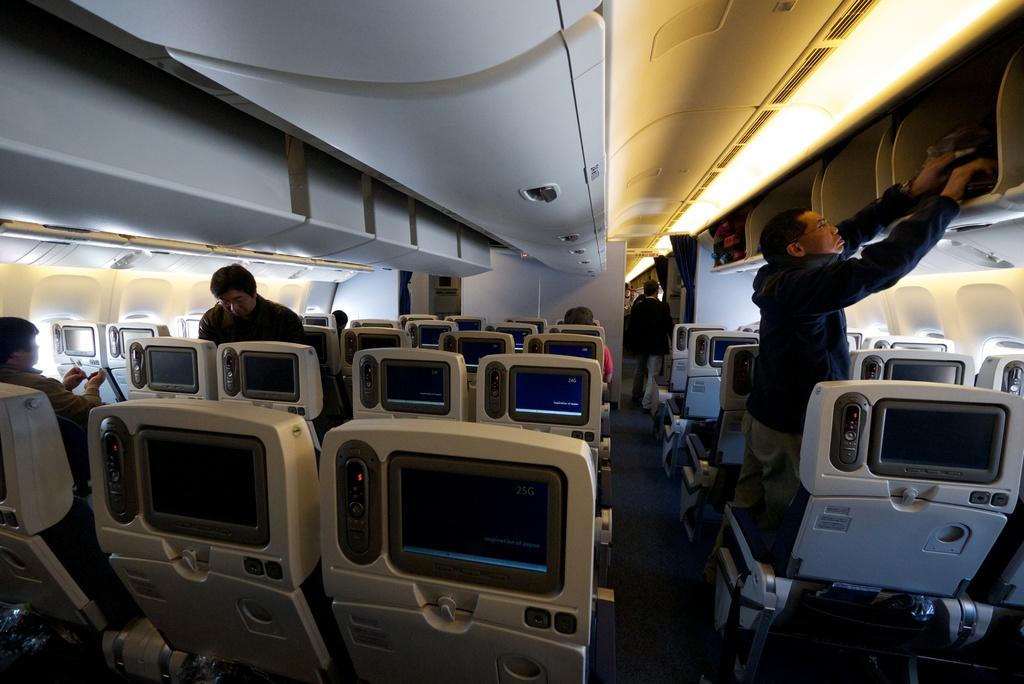How many people are present in the image? There are five persons in the image. What can be seen in the image besides the people? Systems and seats are visible in the image. From where might the image have been taken? The image appears to be taken from a rooftop or a high vantage point. What is the possible location or context of the image? The image may have been taken inside a vehicle. What type of education can be seen being provided in the image? There is no indication of education being provided in the image; it primarily features people, systems, and seats. Can you tell me how many veins are visible in the image? There are no veins visible in the image. 